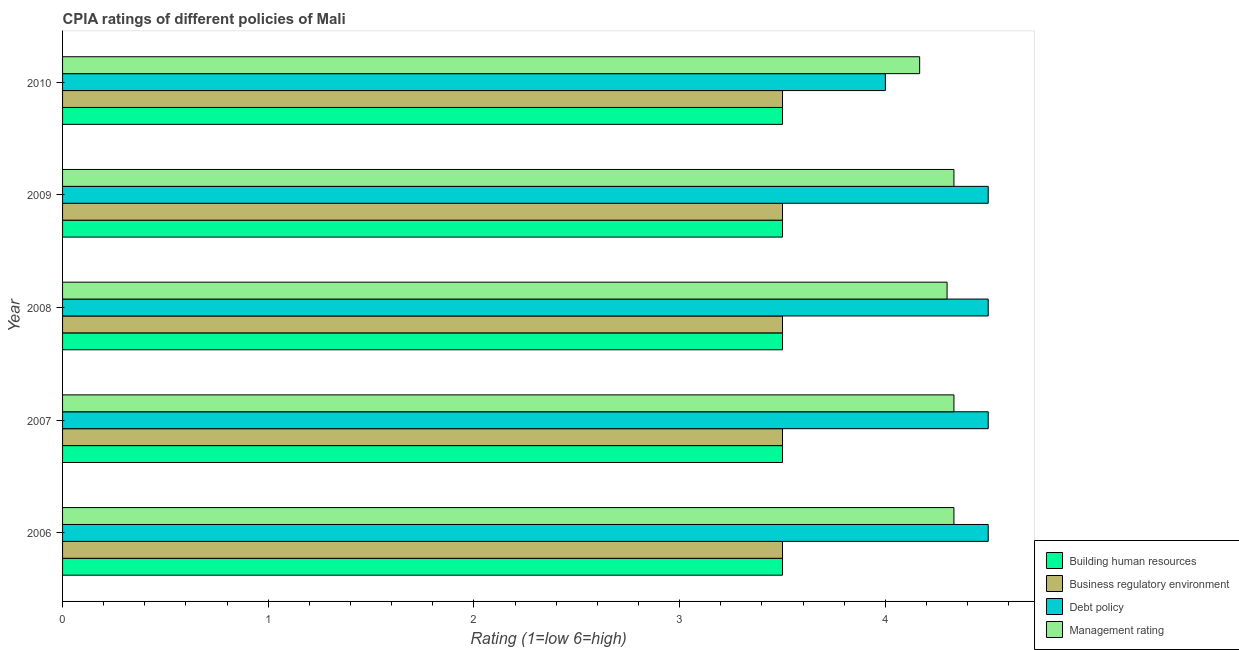Are the number of bars per tick equal to the number of legend labels?
Your answer should be compact. Yes. Are the number of bars on each tick of the Y-axis equal?
Ensure brevity in your answer.  Yes. How many bars are there on the 5th tick from the bottom?
Make the answer very short. 4. In how many cases, is the number of bars for a given year not equal to the number of legend labels?
Ensure brevity in your answer.  0. Across all years, what is the maximum cpia rating of building human resources?
Offer a terse response. 3.5. Across all years, what is the minimum cpia rating of management?
Your response must be concise. 4.17. In which year was the cpia rating of debt policy minimum?
Give a very brief answer. 2010. What is the total cpia rating of management in the graph?
Provide a short and direct response. 21.47. What is the difference between the cpia rating of debt policy in 2007 and that in 2010?
Make the answer very short. 0.5. What is the difference between the cpia rating of management in 2006 and the cpia rating of building human resources in 2008?
Your answer should be very brief. 0.83. What is the average cpia rating of management per year?
Your answer should be very brief. 4.29. In the year 2008, what is the difference between the cpia rating of debt policy and cpia rating of business regulatory environment?
Provide a short and direct response. 1. In how many years, is the cpia rating of debt policy greater than 3 ?
Your answer should be very brief. 5. What is the ratio of the cpia rating of business regulatory environment in 2006 to that in 2007?
Your response must be concise. 1. Is the cpia rating of management in 2007 less than that in 2009?
Make the answer very short. No. What is the difference between the highest and the lowest cpia rating of debt policy?
Your response must be concise. 0.5. Is the sum of the cpia rating of debt policy in 2008 and 2009 greater than the maximum cpia rating of management across all years?
Provide a succinct answer. Yes. Is it the case that in every year, the sum of the cpia rating of debt policy and cpia rating of management is greater than the sum of cpia rating of business regulatory environment and cpia rating of building human resources?
Offer a terse response. Yes. What does the 1st bar from the top in 2009 represents?
Offer a terse response. Management rating. What does the 1st bar from the bottom in 2010 represents?
Your answer should be compact. Building human resources. Is it the case that in every year, the sum of the cpia rating of building human resources and cpia rating of business regulatory environment is greater than the cpia rating of debt policy?
Offer a very short reply. Yes. What is the difference between two consecutive major ticks on the X-axis?
Ensure brevity in your answer.  1. Are the values on the major ticks of X-axis written in scientific E-notation?
Your answer should be compact. No. Does the graph contain any zero values?
Give a very brief answer. No. Does the graph contain grids?
Provide a succinct answer. No. Where does the legend appear in the graph?
Make the answer very short. Bottom right. How many legend labels are there?
Ensure brevity in your answer.  4. How are the legend labels stacked?
Keep it short and to the point. Vertical. What is the title of the graph?
Provide a short and direct response. CPIA ratings of different policies of Mali. Does "Belgium" appear as one of the legend labels in the graph?
Provide a short and direct response. No. What is the label or title of the X-axis?
Offer a terse response. Rating (1=low 6=high). What is the Rating (1=low 6=high) of Management rating in 2006?
Give a very brief answer. 4.33. What is the Rating (1=low 6=high) in Building human resources in 2007?
Your response must be concise. 3.5. What is the Rating (1=low 6=high) in Business regulatory environment in 2007?
Ensure brevity in your answer.  3.5. What is the Rating (1=low 6=high) of Debt policy in 2007?
Ensure brevity in your answer.  4.5. What is the Rating (1=low 6=high) in Management rating in 2007?
Your response must be concise. 4.33. What is the Rating (1=low 6=high) in Building human resources in 2008?
Make the answer very short. 3.5. What is the Rating (1=low 6=high) of Debt policy in 2008?
Ensure brevity in your answer.  4.5. What is the Rating (1=low 6=high) in Building human resources in 2009?
Give a very brief answer. 3.5. What is the Rating (1=low 6=high) of Business regulatory environment in 2009?
Ensure brevity in your answer.  3.5. What is the Rating (1=low 6=high) of Management rating in 2009?
Ensure brevity in your answer.  4.33. What is the Rating (1=low 6=high) of Building human resources in 2010?
Your answer should be compact. 3.5. What is the Rating (1=low 6=high) in Debt policy in 2010?
Make the answer very short. 4. What is the Rating (1=low 6=high) of Management rating in 2010?
Your answer should be compact. 4.17. Across all years, what is the maximum Rating (1=low 6=high) in Building human resources?
Ensure brevity in your answer.  3.5. Across all years, what is the maximum Rating (1=low 6=high) of Business regulatory environment?
Provide a short and direct response. 3.5. Across all years, what is the maximum Rating (1=low 6=high) of Debt policy?
Ensure brevity in your answer.  4.5. Across all years, what is the maximum Rating (1=low 6=high) in Management rating?
Give a very brief answer. 4.33. Across all years, what is the minimum Rating (1=low 6=high) in Building human resources?
Your answer should be very brief. 3.5. Across all years, what is the minimum Rating (1=low 6=high) in Management rating?
Your response must be concise. 4.17. What is the total Rating (1=low 6=high) in Building human resources in the graph?
Offer a terse response. 17.5. What is the total Rating (1=low 6=high) in Business regulatory environment in the graph?
Make the answer very short. 17.5. What is the total Rating (1=low 6=high) of Management rating in the graph?
Your answer should be compact. 21.47. What is the difference between the Rating (1=low 6=high) in Building human resources in 2006 and that in 2007?
Your answer should be compact. 0. What is the difference between the Rating (1=low 6=high) of Management rating in 2006 and that in 2007?
Give a very brief answer. 0. What is the difference between the Rating (1=low 6=high) in Business regulatory environment in 2006 and that in 2008?
Provide a succinct answer. 0. What is the difference between the Rating (1=low 6=high) in Management rating in 2006 and that in 2008?
Offer a terse response. 0.03. What is the difference between the Rating (1=low 6=high) in Business regulatory environment in 2006 and that in 2009?
Your answer should be compact. 0. What is the difference between the Rating (1=low 6=high) in Debt policy in 2006 and that in 2009?
Offer a terse response. 0. What is the difference between the Rating (1=low 6=high) of Building human resources in 2006 and that in 2010?
Provide a short and direct response. 0. What is the difference between the Rating (1=low 6=high) of Debt policy in 2006 and that in 2010?
Provide a short and direct response. 0.5. What is the difference between the Rating (1=low 6=high) in Management rating in 2006 and that in 2010?
Your response must be concise. 0.17. What is the difference between the Rating (1=low 6=high) in Business regulatory environment in 2007 and that in 2008?
Give a very brief answer. 0. What is the difference between the Rating (1=low 6=high) in Management rating in 2007 and that in 2008?
Your response must be concise. 0.03. What is the difference between the Rating (1=low 6=high) of Building human resources in 2007 and that in 2009?
Your answer should be very brief. 0. What is the difference between the Rating (1=low 6=high) of Debt policy in 2007 and that in 2009?
Make the answer very short. 0. What is the difference between the Rating (1=low 6=high) of Management rating in 2007 and that in 2009?
Provide a short and direct response. 0. What is the difference between the Rating (1=low 6=high) of Building human resources in 2007 and that in 2010?
Your response must be concise. 0. What is the difference between the Rating (1=low 6=high) in Building human resources in 2008 and that in 2009?
Your answer should be very brief. 0. What is the difference between the Rating (1=low 6=high) in Business regulatory environment in 2008 and that in 2009?
Make the answer very short. 0. What is the difference between the Rating (1=low 6=high) of Management rating in 2008 and that in 2009?
Your answer should be compact. -0.03. What is the difference between the Rating (1=low 6=high) in Management rating in 2008 and that in 2010?
Make the answer very short. 0.13. What is the difference between the Rating (1=low 6=high) of Building human resources in 2009 and that in 2010?
Make the answer very short. 0. What is the difference between the Rating (1=low 6=high) of Debt policy in 2009 and that in 2010?
Your response must be concise. 0.5. What is the difference between the Rating (1=low 6=high) in Building human resources in 2006 and the Rating (1=low 6=high) in Debt policy in 2007?
Your answer should be compact. -1. What is the difference between the Rating (1=low 6=high) of Business regulatory environment in 2006 and the Rating (1=low 6=high) of Debt policy in 2007?
Your answer should be very brief. -1. What is the difference between the Rating (1=low 6=high) of Debt policy in 2006 and the Rating (1=low 6=high) of Management rating in 2007?
Offer a very short reply. 0.17. What is the difference between the Rating (1=low 6=high) in Building human resources in 2006 and the Rating (1=low 6=high) in Business regulatory environment in 2008?
Give a very brief answer. 0. What is the difference between the Rating (1=low 6=high) in Building human resources in 2006 and the Rating (1=low 6=high) in Debt policy in 2008?
Offer a terse response. -1. What is the difference between the Rating (1=low 6=high) in Business regulatory environment in 2006 and the Rating (1=low 6=high) in Management rating in 2008?
Keep it short and to the point. -0.8. What is the difference between the Rating (1=low 6=high) in Building human resources in 2006 and the Rating (1=low 6=high) in Business regulatory environment in 2009?
Offer a terse response. 0. What is the difference between the Rating (1=low 6=high) of Building human resources in 2006 and the Rating (1=low 6=high) of Management rating in 2009?
Provide a short and direct response. -0.83. What is the difference between the Rating (1=low 6=high) in Business regulatory environment in 2006 and the Rating (1=low 6=high) in Debt policy in 2009?
Keep it short and to the point. -1. What is the difference between the Rating (1=low 6=high) of Building human resources in 2006 and the Rating (1=low 6=high) of Debt policy in 2010?
Offer a very short reply. -0.5. What is the difference between the Rating (1=low 6=high) of Building human resources in 2006 and the Rating (1=low 6=high) of Management rating in 2010?
Your answer should be compact. -0.67. What is the difference between the Rating (1=low 6=high) of Business regulatory environment in 2006 and the Rating (1=low 6=high) of Debt policy in 2010?
Your response must be concise. -0.5. What is the difference between the Rating (1=low 6=high) in Building human resources in 2007 and the Rating (1=low 6=high) in Business regulatory environment in 2008?
Offer a very short reply. 0. What is the difference between the Rating (1=low 6=high) in Business regulatory environment in 2007 and the Rating (1=low 6=high) in Debt policy in 2008?
Your answer should be very brief. -1. What is the difference between the Rating (1=low 6=high) of Business regulatory environment in 2007 and the Rating (1=low 6=high) of Management rating in 2008?
Your response must be concise. -0.8. What is the difference between the Rating (1=low 6=high) of Building human resources in 2007 and the Rating (1=low 6=high) of Business regulatory environment in 2009?
Offer a very short reply. 0. What is the difference between the Rating (1=low 6=high) of Building human resources in 2007 and the Rating (1=low 6=high) of Business regulatory environment in 2010?
Keep it short and to the point. 0. What is the difference between the Rating (1=low 6=high) in Building human resources in 2007 and the Rating (1=low 6=high) in Debt policy in 2010?
Offer a terse response. -0.5. What is the difference between the Rating (1=low 6=high) of Business regulatory environment in 2007 and the Rating (1=low 6=high) of Management rating in 2010?
Your answer should be very brief. -0.67. What is the difference between the Rating (1=low 6=high) of Debt policy in 2007 and the Rating (1=low 6=high) of Management rating in 2010?
Provide a short and direct response. 0.33. What is the difference between the Rating (1=low 6=high) in Building human resources in 2008 and the Rating (1=low 6=high) in Debt policy in 2009?
Give a very brief answer. -1. What is the difference between the Rating (1=low 6=high) in Debt policy in 2008 and the Rating (1=low 6=high) in Management rating in 2009?
Provide a succinct answer. 0.17. What is the difference between the Rating (1=low 6=high) in Building human resources in 2008 and the Rating (1=low 6=high) in Business regulatory environment in 2010?
Ensure brevity in your answer.  0. What is the difference between the Rating (1=low 6=high) of Building human resources in 2008 and the Rating (1=low 6=high) of Debt policy in 2010?
Your answer should be very brief. -0.5. What is the difference between the Rating (1=low 6=high) in Business regulatory environment in 2008 and the Rating (1=low 6=high) in Debt policy in 2010?
Offer a very short reply. -0.5. What is the difference between the Rating (1=low 6=high) of Debt policy in 2008 and the Rating (1=low 6=high) of Management rating in 2010?
Ensure brevity in your answer.  0.33. What is the difference between the Rating (1=low 6=high) in Building human resources in 2009 and the Rating (1=low 6=high) in Business regulatory environment in 2010?
Your answer should be compact. 0. What is the difference between the Rating (1=low 6=high) in Building human resources in 2009 and the Rating (1=low 6=high) in Management rating in 2010?
Keep it short and to the point. -0.67. What is the difference between the Rating (1=low 6=high) of Business regulatory environment in 2009 and the Rating (1=low 6=high) of Debt policy in 2010?
Give a very brief answer. -0.5. What is the average Rating (1=low 6=high) of Management rating per year?
Provide a short and direct response. 4.29. In the year 2006, what is the difference between the Rating (1=low 6=high) of Building human resources and Rating (1=low 6=high) of Business regulatory environment?
Keep it short and to the point. 0. In the year 2006, what is the difference between the Rating (1=low 6=high) of Building human resources and Rating (1=low 6=high) of Debt policy?
Give a very brief answer. -1. In the year 2007, what is the difference between the Rating (1=low 6=high) of Building human resources and Rating (1=low 6=high) of Debt policy?
Keep it short and to the point. -1. In the year 2007, what is the difference between the Rating (1=low 6=high) of Building human resources and Rating (1=low 6=high) of Management rating?
Keep it short and to the point. -0.83. In the year 2007, what is the difference between the Rating (1=low 6=high) of Business regulatory environment and Rating (1=low 6=high) of Management rating?
Your answer should be very brief. -0.83. In the year 2007, what is the difference between the Rating (1=low 6=high) in Debt policy and Rating (1=low 6=high) in Management rating?
Your answer should be very brief. 0.17. In the year 2008, what is the difference between the Rating (1=low 6=high) in Business regulatory environment and Rating (1=low 6=high) in Debt policy?
Your answer should be compact. -1. In the year 2008, what is the difference between the Rating (1=low 6=high) in Business regulatory environment and Rating (1=low 6=high) in Management rating?
Make the answer very short. -0.8. In the year 2009, what is the difference between the Rating (1=low 6=high) in Building human resources and Rating (1=low 6=high) in Business regulatory environment?
Your response must be concise. 0. In the year 2009, what is the difference between the Rating (1=low 6=high) in Building human resources and Rating (1=low 6=high) in Management rating?
Keep it short and to the point. -0.83. In the year 2009, what is the difference between the Rating (1=low 6=high) in Business regulatory environment and Rating (1=low 6=high) in Debt policy?
Your response must be concise. -1. In the year 2009, what is the difference between the Rating (1=low 6=high) in Debt policy and Rating (1=low 6=high) in Management rating?
Your answer should be very brief. 0.17. In the year 2010, what is the difference between the Rating (1=low 6=high) in Building human resources and Rating (1=low 6=high) in Debt policy?
Your response must be concise. -0.5. In the year 2010, what is the difference between the Rating (1=low 6=high) of Business regulatory environment and Rating (1=low 6=high) of Debt policy?
Provide a short and direct response. -0.5. In the year 2010, what is the difference between the Rating (1=low 6=high) in Business regulatory environment and Rating (1=low 6=high) in Management rating?
Your answer should be compact. -0.67. What is the ratio of the Rating (1=low 6=high) in Business regulatory environment in 2006 to that in 2007?
Give a very brief answer. 1. What is the ratio of the Rating (1=low 6=high) of Building human resources in 2006 to that in 2008?
Your answer should be compact. 1. What is the ratio of the Rating (1=low 6=high) in Business regulatory environment in 2006 to that in 2008?
Your answer should be very brief. 1. What is the ratio of the Rating (1=low 6=high) in Management rating in 2006 to that in 2008?
Ensure brevity in your answer.  1.01. What is the ratio of the Rating (1=low 6=high) in Building human resources in 2006 to that in 2009?
Your response must be concise. 1. What is the ratio of the Rating (1=low 6=high) of Business regulatory environment in 2006 to that in 2009?
Your response must be concise. 1. What is the ratio of the Rating (1=low 6=high) in Debt policy in 2006 to that in 2009?
Give a very brief answer. 1. What is the ratio of the Rating (1=low 6=high) of Debt policy in 2006 to that in 2010?
Give a very brief answer. 1.12. What is the ratio of the Rating (1=low 6=high) in Management rating in 2006 to that in 2010?
Offer a terse response. 1.04. What is the ratio of the Rating (1=low 6=high) in Building human resources in 2007 to that in 2008?
Your answer should be compact. 1. What is the ratio of the Rating (1=low 6=high) of Debt policy in 2007 to that in 2008?
Offer a terse response. 1. What is the ratio of the Rating (1=low 6=high) of Business regulatory environment in 2007 to that in 2009?
Keep it short and to the point. 1. What is the ratio of the Rating (1=low 6=high) in Management rating in 2007 to that in 2009?
Your answer should be compact. 1. What is the ratio of the Rating (1=low 6=high) in Debt policy in 2007 to that in 2010?
Give a very brief answer. 1.12. What is the ratio of the Rating (1=low 6=high) in Management rating in 2007 to that in 2010?
Make the answer very short. 1.04. What is the ratio of the Rating (1=low 6=high) of Building human resources in 2008 to that in 2009?
Provide a succinct answer. 1. What is the ratio of the Rating (1=low 6=high) in Business regulatory environment in 2008 to that in 2009?
Offer a terse response. 1. What is the ratio of the Rating (1=low 6=high) of Debt policy in 2008 to that in 2009?
Keep it short and to the point. 1. What is the ratio of the Rating (1=low 6=high) of Management rating in 2008 to that in 2009?
Provide a short and direct response. 0.99. What is the ratio of the Rating (1=low 6=high) in Business regulatory environment in 2008 to that in 2010?
Provide a short and direct response. 1. What is the ratio of the Rating (1=low 6=high) in Debt policy in 2008 to that in 2010?
Provide a short and direct response. 1.12. What is the ratio of the Rating (1=low 6=high) in Management rating in 2008 to that in 2010?
Your answer should be very brief. 1.03. What is the difference between the highest and the second highest Rating (1=low 6=high) in Building human resources?
Offer a very short reply. 0. What is the difference between the highest and the second highest Rating (1=low 6=high) of Debt policy?
Your response must be concise. 0. What is the difference between the highest and the second highest Rating (1=low 6=high) in Management rating?
Your response must be concise. 0. What is the difference between the highest and the lowest Rating (1=low 6=high) of Building human resources?
Offer a very short reply. 0. What is the difference between the highest and the lowest Rating (1=low 6=high) of Business regulatory environment?
Offer a terse response. 0. 